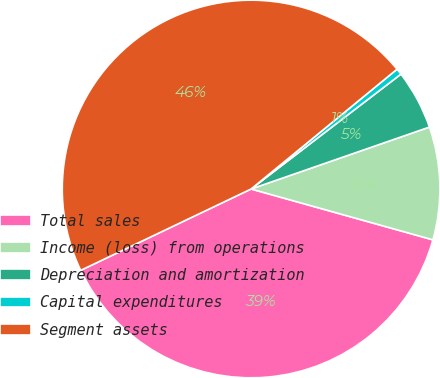Convert chart to OTSL. <chart><loc_0><loc_0><loc_500><loc_500><pie_chart><fcel>Total sales<fcel>Income (loss) from operations<fcel>Depreciation and amortization<fcel>Capital expenditures<fcel>Segment assets<nl><fcel>38.57%<fcel>9.66%<fcel>5.09%<fcel>0.53%<fcel>46.15%<nl></chart> 